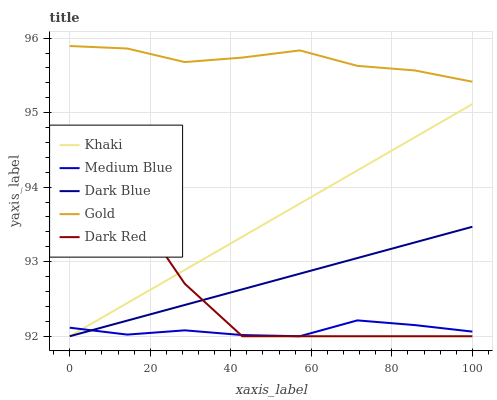Does Medium Blue have the minimum area under the curve?
Answer yes or no. Yes. Does Gold have the maximum area under the curve?
Answer yes or no. Yes. Does Khaki have the minimum area under the curve?
Answer yes or no. No. Does Khaki have the maximum area under the curve?
Answer yes or no. No. Is Dark Blue the smoothest?
Answer yes or no. Yes. Is Dark Red the roughest?
Answer yes or no. Yes. Is Khaki the smoothest?
Answer yes or no. No. Is Khaki the roughest?
Answer yes or no. No. Does Dark Blue have the lowest value?
Answer yes or no. Yes. Does Gold have the lowest value?
Answer yes or no. No. Does Gold have the highest value?
Answer yes or no. Yes. Does Khaki have the highest value?
Answer yes or no. No. Is Dark Blue less than Gold?
Answer yes or no. Yes. Is Gold greater than Khaki?
Answer yes or no. Yes. Does Dark Red intersect Khaki?
Answer yes or no. Yes. Is Dark Red less than Khaki?
Answer yes or no. No. Is Dark Red greater than Khaki?
Answer yes or no. No. Does Dark Blue intersect Gold?
Answer yes or no. No. 